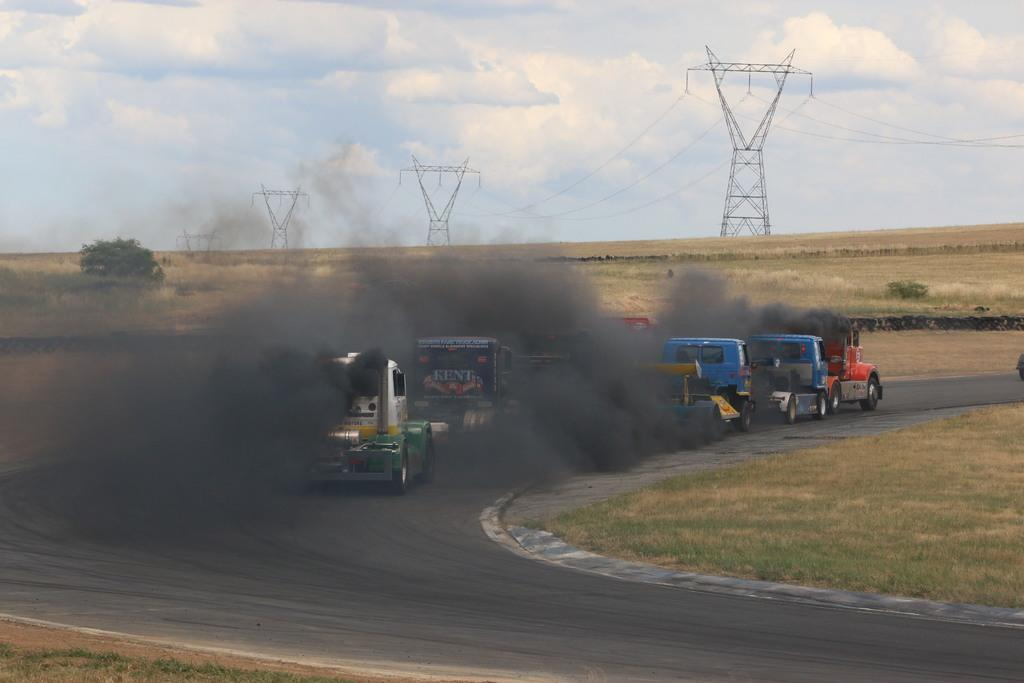What can be seen on the road in the image? There are vehicles on the road in the image. What is visible in the background of the image? There are trees and power towers in the background of the image. What is visible in the sky in the image? The sky is visible in the background of the image, and clouds are present in the sky. What type of tray is being used to transport the power towers in the image? There is no tray present in the image, and power towers are not being transported. What muscle is being exercised by the clouds in the image? There are no muscles or exercises depicted in the image; clouds are a natural atmospheric phenomenon. 